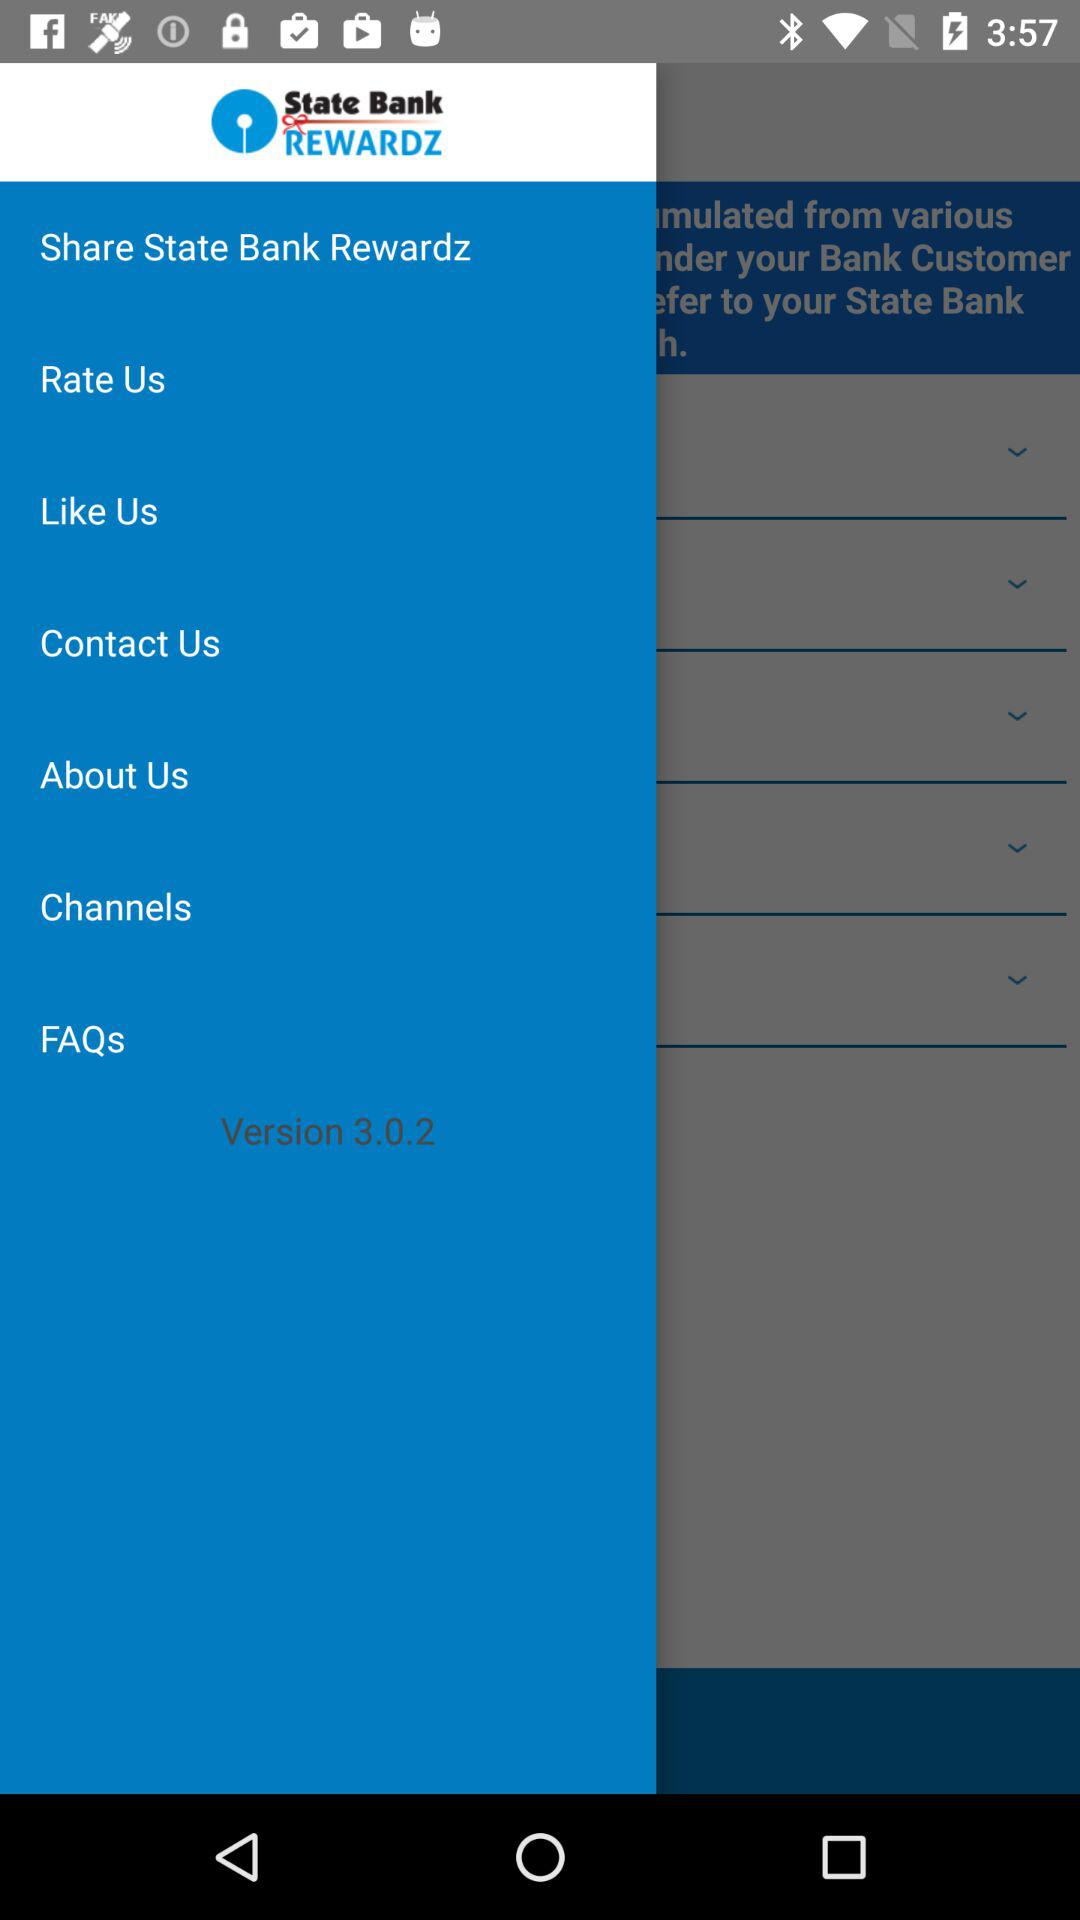What is the application name? The application name is "State Bank REWARDZ". 